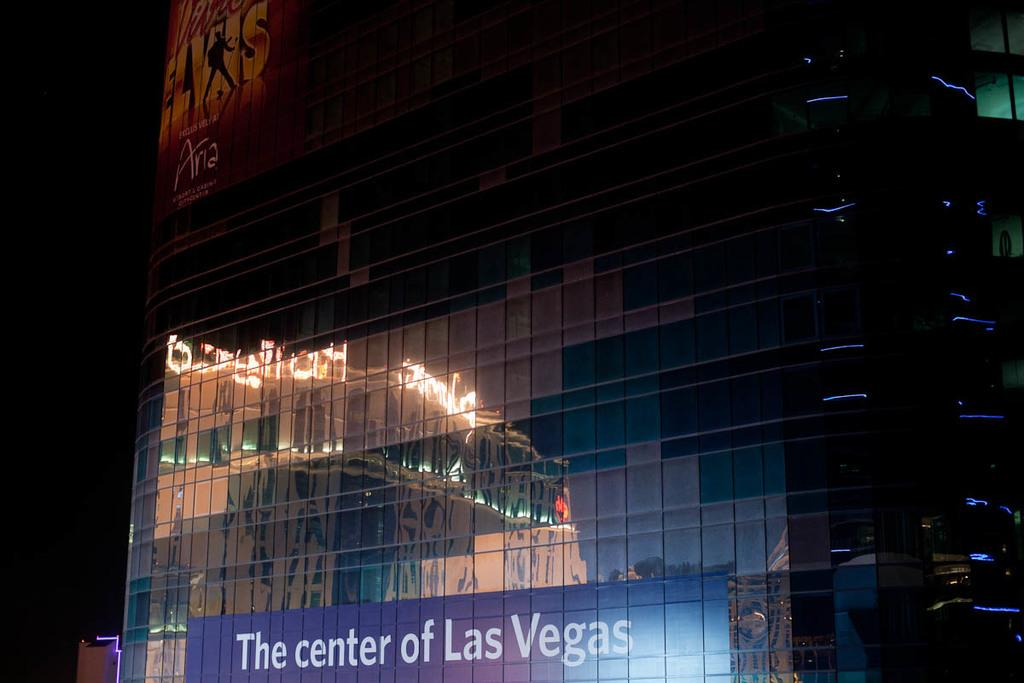What is the overall appearance of the image? The image is dark. What type of structure can be seen in the image? There is a building in the image. What feature does the building have? The building has architectural glass. What is written or displayed on the glass? There is text on the glass. How many dogs are sitting on the stove in the image? There are no dogs or stoves present in the image. What type of yak can be seen grazing near the building in the image? There are no yaks present in the image; it only features a building with architectural glass and text on the glass. 